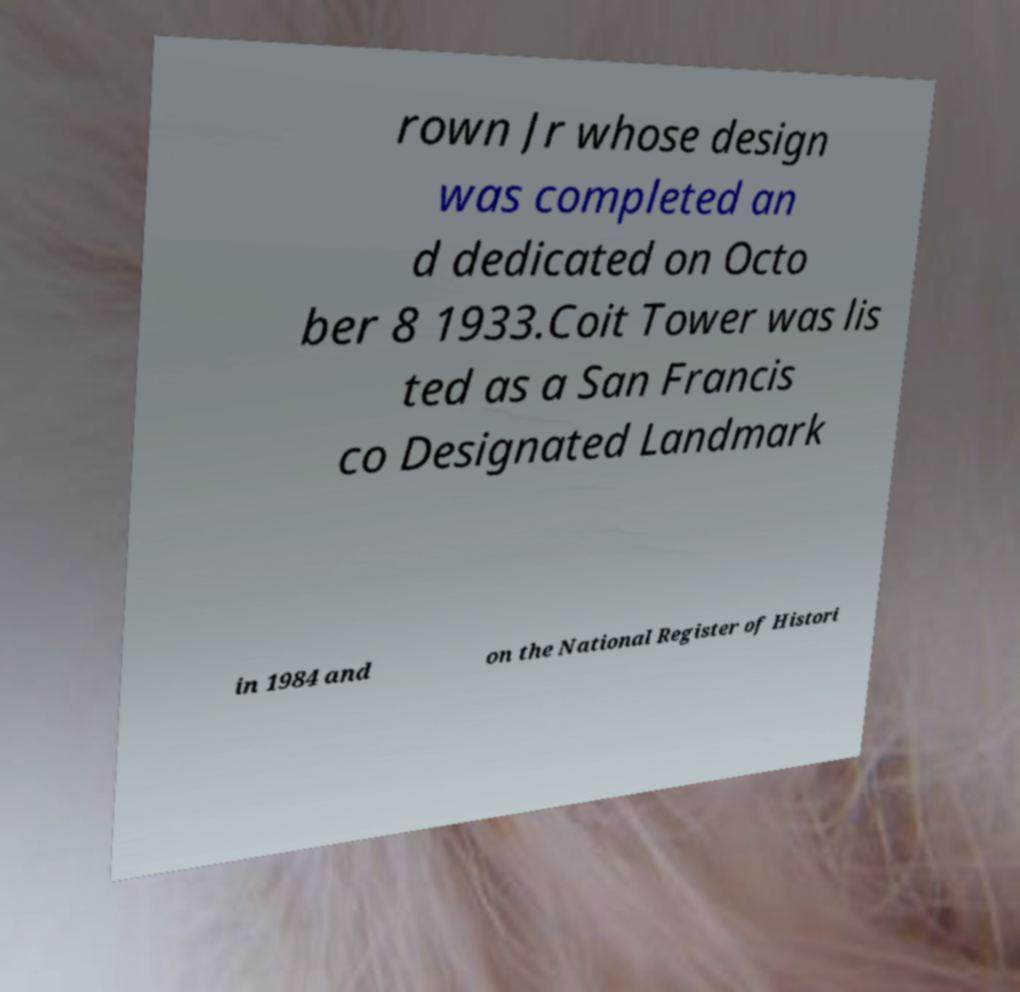For documentation purposes, I need the text within this image transcribed. Could you provide that? rown Jr whose design was completed an d dedicated on Octo ber 8 1933.Coit Tower was lis ted as a San Francis co Designated Landmark in 1984 and on the National Register of Histori 